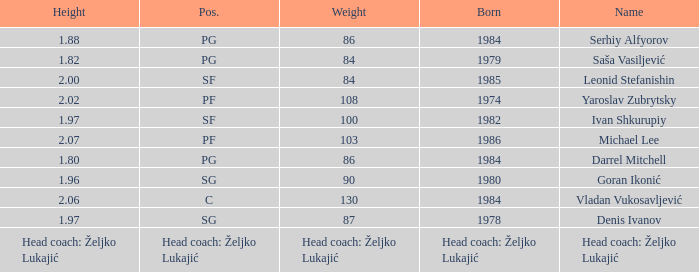What is the weight of the player with a height of 2.00m? 84.0. 